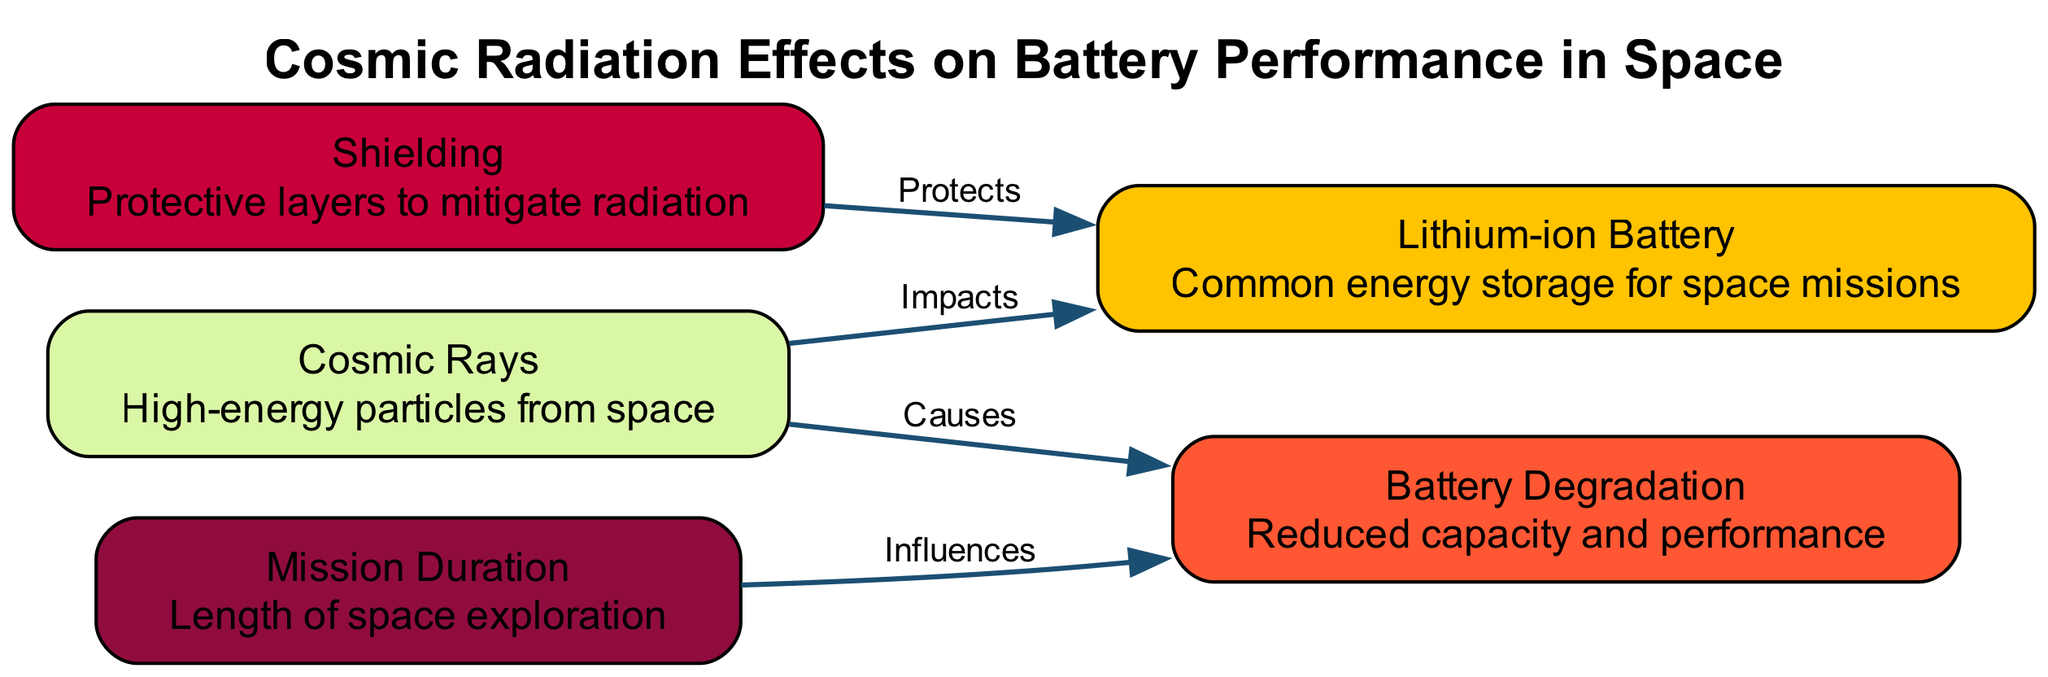What is the primary type of battery shown in the diagram? The diagram identifies "Lithium-ion Battery" as the primary type of battery, as stated in the node description.
Answer: Lithium-ion Battery How many nodes are present in the diagram? Counting each listed node (1 to 5) as shown in the diagram, the total number of nodes is 5.
Answer: 5 What does cosmic rays cause in batteries? According to the diagram, cosmic rays are linked to "Battery Degradation," which indicates the adverse effects they have on battery performance.
Answer: Battery Degradation What does shielding do in relation to the lithium-ion battery? The diagram indicates that shielding "Protects" the lithium-ion battery from cosmic radiation effects, illustrating its function as a protective measure.
Answer: Protects Which factor influences battery degradation according to the mission duration? The diagram states that "Mission Duration" influences "Battery Degradation," which implies longer missions may lead to greater degradation.
Answer: Influences How many edges connect "Cosmic Rays" to other nodes? The edges show that "Cosmic Rays" connects to two other nodes: "Lithium-ion Battery" and "Battery Degradation," totaling two connections.
Answer: 2 Which element is described as high-energy particles from space? The node specifically identifies "Cosmic Rays" as the element characterized by being high-energy particles originating from space.
Answer: Cosmic Rays What is the impact of cosmic rays on the battery? The impact of cosmic rays on the battery is defined as "Impacts" in the relationship shown in the diagram, indicating a direct effect on battery performance.
Answer: Impacts What does the diagram indicate about the relationship between mission duration and battery degradation? The relationship is indicated as "Influences," meaning that the length of the mission period affects the extent of battery degradation faced during that time.
Answer: Influences 